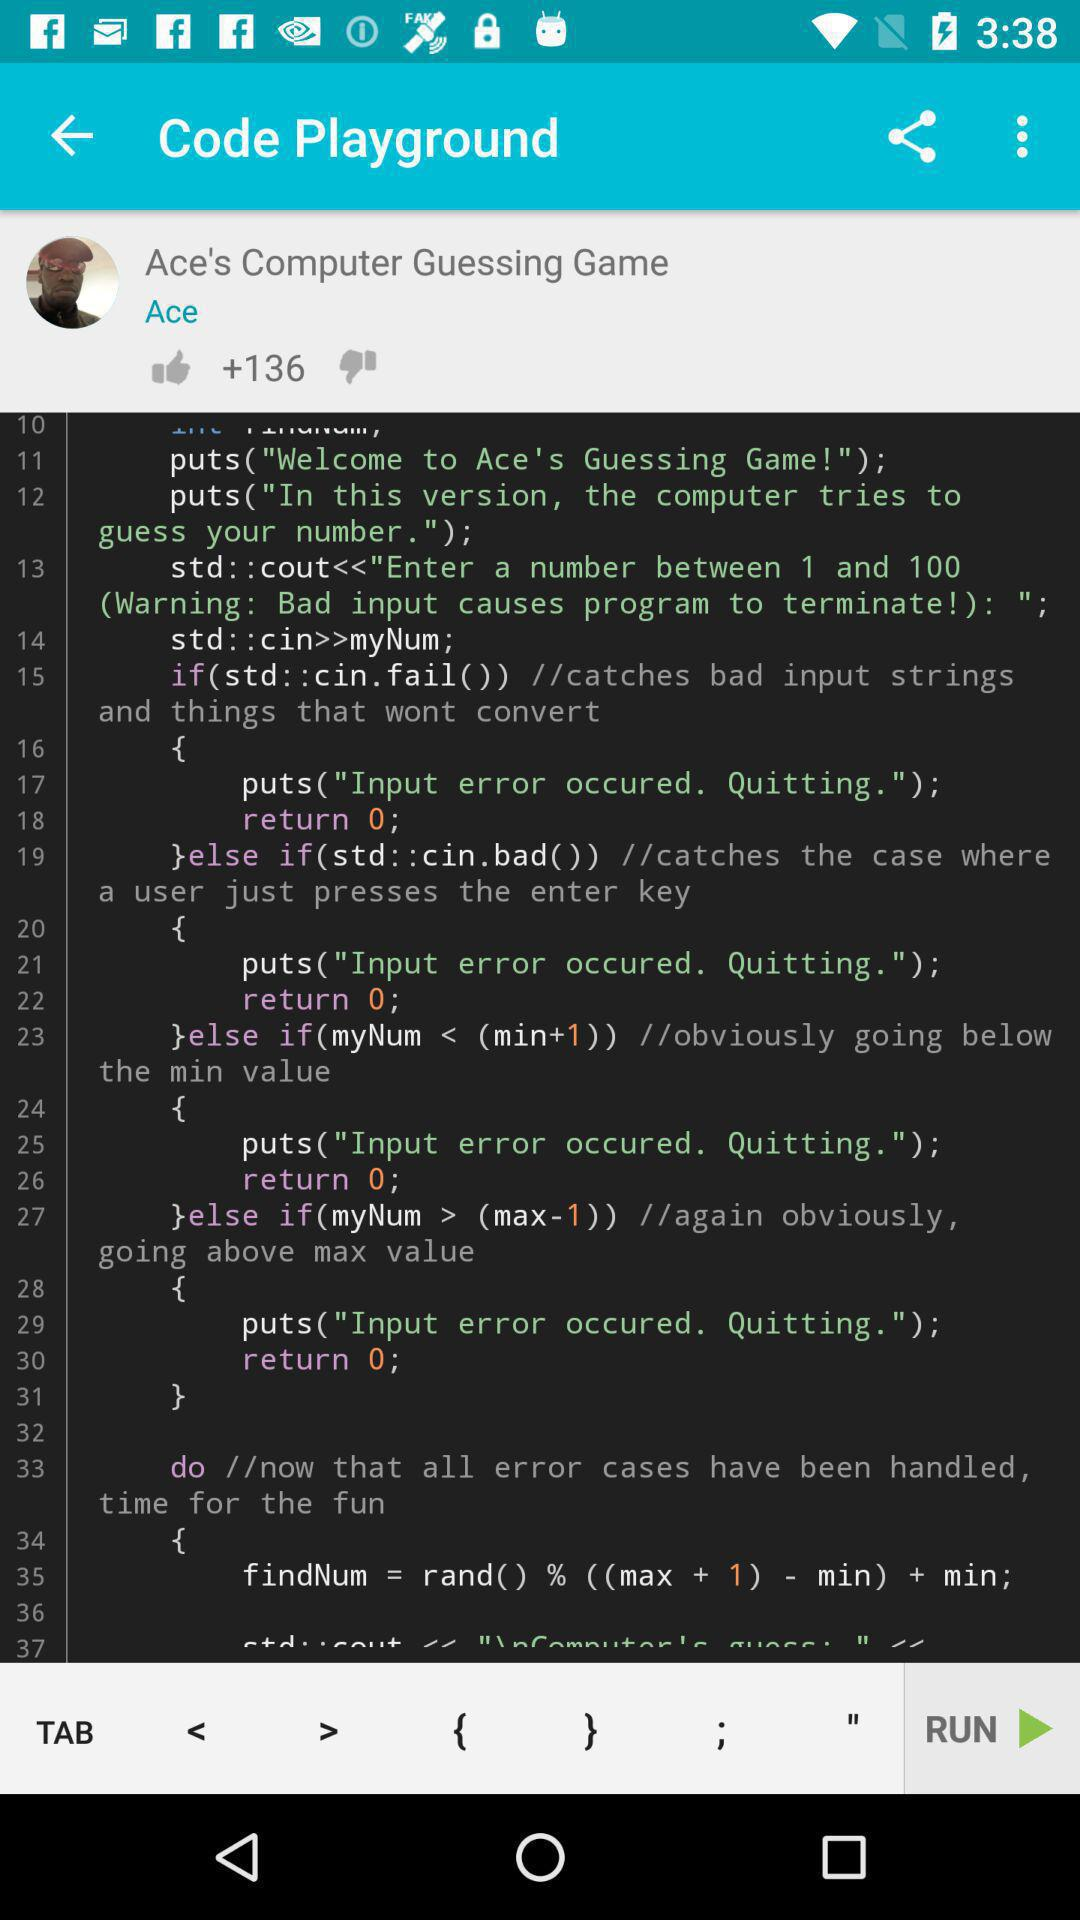What is the name of the game? The name of the game is "Ace's Computer Guessing Game". 